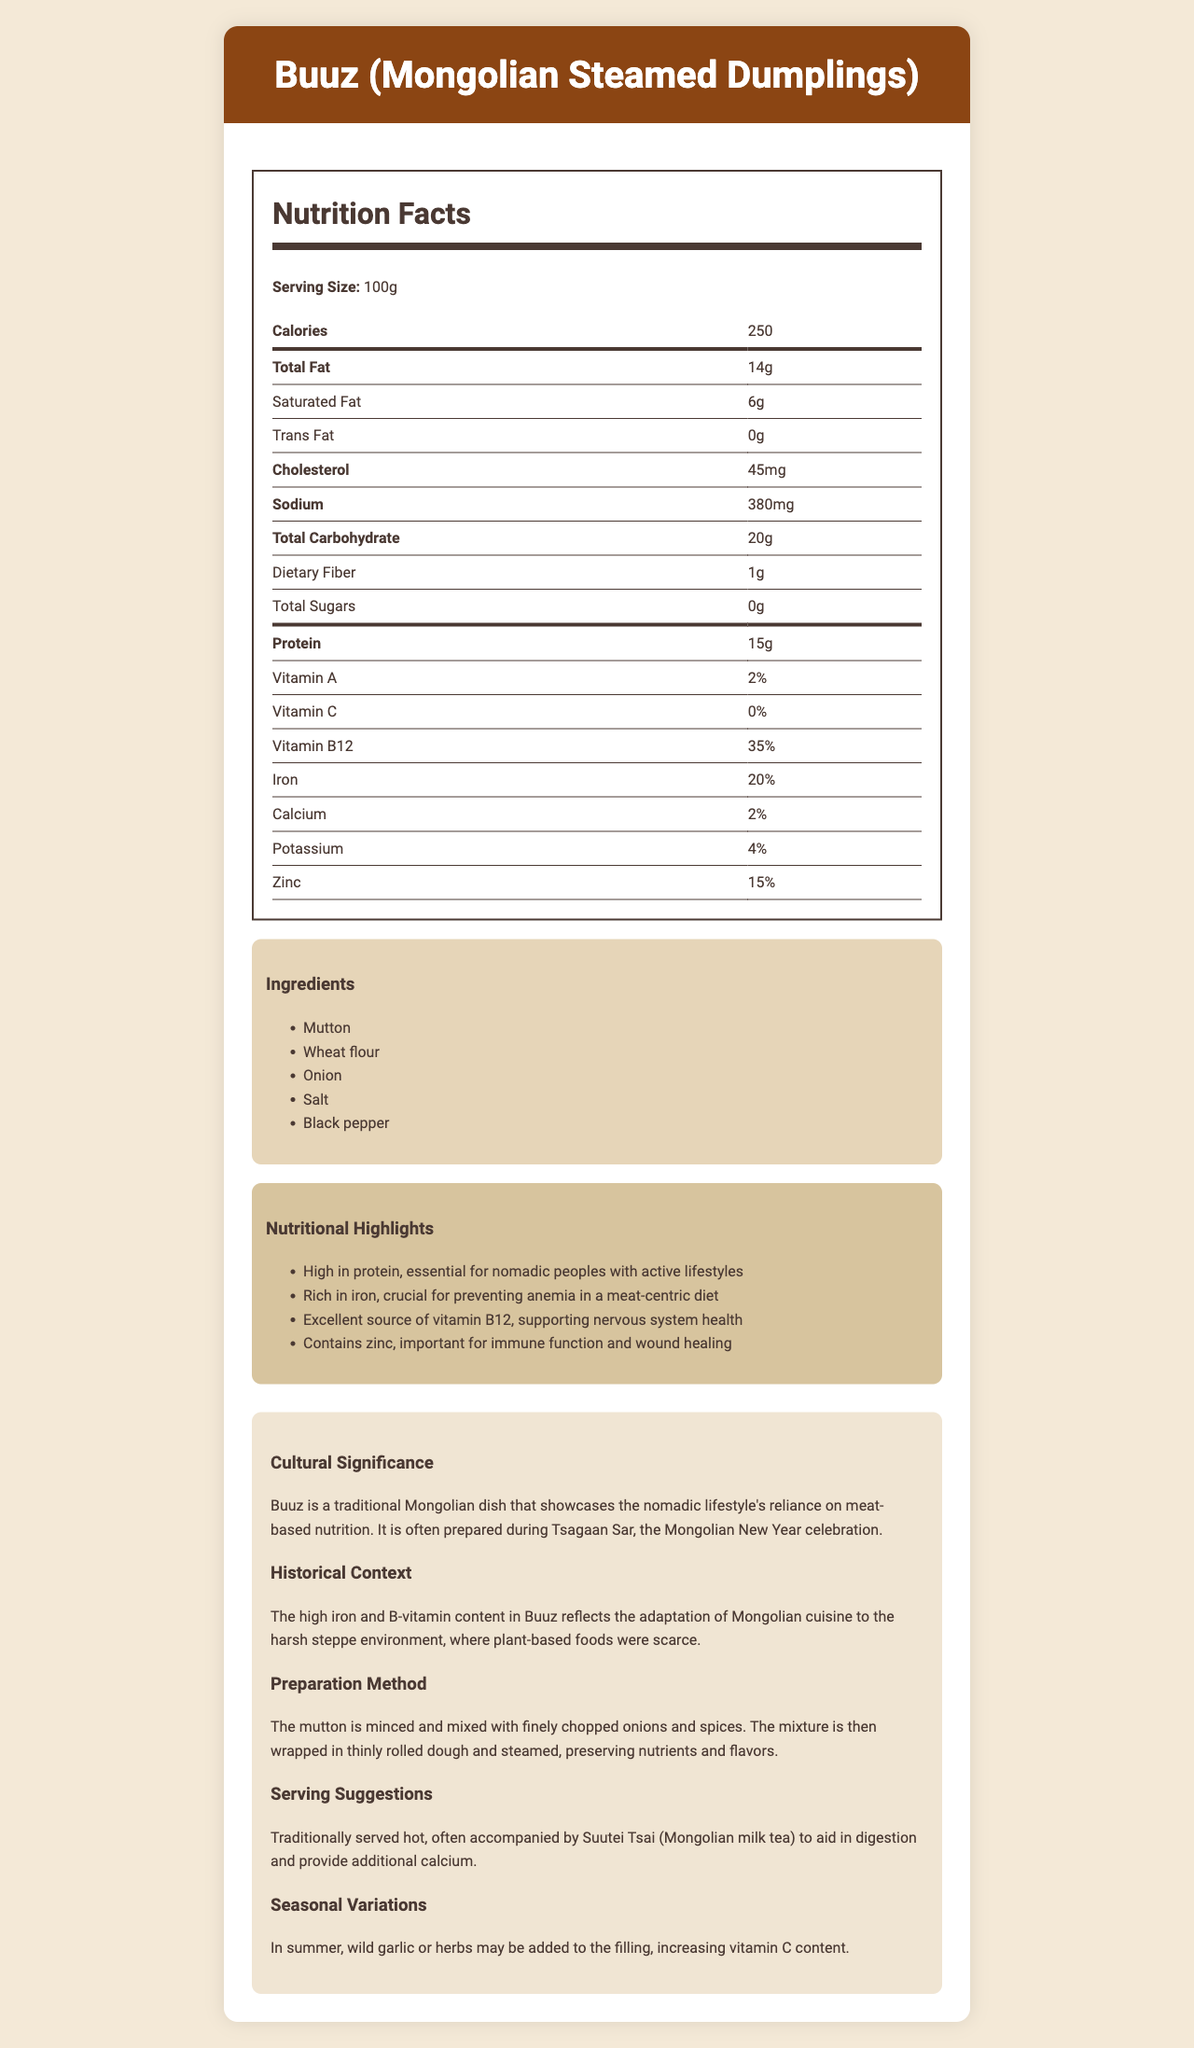what is the serving size for Buuz? The serving size for Buuz is listed as 100g in the nutrition facts section of the document.
Answer: 100g how many calories are in a serving of Buuz? The document states that there are 250 calories in a 100g serving of Buuz.
Answer: 250 what is the main ingredient in Buuz? According to the ingredients list, the main ingredient in Buuz is mutton.
Answer: Mutton what percentage of Vitamin B12 is in Buuz? The nutrition label indicates that Buuz provides 35% of the daily value of Vitamin B12.
Answer: 35% what is the sodium content in Buuz? The nutrition facts section lists the sodium content as 380mg per serving.
Answer: 380mg what event is Buuz often prepared for? The document states that Buuz is often prepared during Tsagaan Sar, the Mongolian New Year celebration.
Answer: Tsagaan Sar which of the following nutrients is Buuz particularly high in? A. Vitamin C B. Iron C. Calcium The nutrition highlights section states that Buuz is rich in iron, making it a crucial part of the diet to prevent anemia.
Answer: B. Iron what is the traditional beverage served with Buuz? A. Airag B. Suutei Tsai C. Vodka The serving suggestions mention that Buuz is traditionally served with Suutei Tsai (Mongolian milk tea).
Answer: B. Suutei Tsai is Buuz high in trans fat? The nutrition facts label states that Buuz contains 0g of trans fat.
Answer: No describe the cultural and nutritional significance of Buuz. The document describes Buuz as culturally significant for its association with the Mongolian New Year and nutritional significance due to its high protein, iron, Vitamin B12, and zinc content.
Answer: Buuz is a traditional Mongolian dish prepared during Tsagaan Sar, reflecting the nomadic lifestyle's dependency on meat-based nutrition. It is high in protein, iron, Vitamin B12, and zinc, supporting an active lifestyle, preventing anemia, and promoting immune function. what are some seasonal variations of Buuz? The seasonal variations section mentions that during summer, wild garlic or herbs may be added to Buuz, enhancing its vitamin C content.
Answer: Wild garlic or herbs may be added to the filling in summer, increasing vitamin C content. how is Buuz prepared? The preparation method section states that the mutton is minced, mixed with chopped onions and spices, then wrapped in rolled dough and steamed.
Answer: The mutton is minced and mixed with onions and spices, wrapped in dough and steamed. what additional nutrient does Suutei Tsai provide when served with Buuz? The serving suggestions note that Suutei Tsai provides additional calcium.
Answer: Calcium how many grams of protein are in Buuz per serving? The nutrition facts section indicates that Buuz contains 15g of protein per serving.
Answer: 15g can the Vitamin C content of Buuz be determined from the document? The document lists the Vitamin C content as 0%, but seasonal variations suggest it may increase with the addition of wild garlic or herbs. The exact amount cannot be determined based on the visual information provided.
Answer: Cannot be determined 